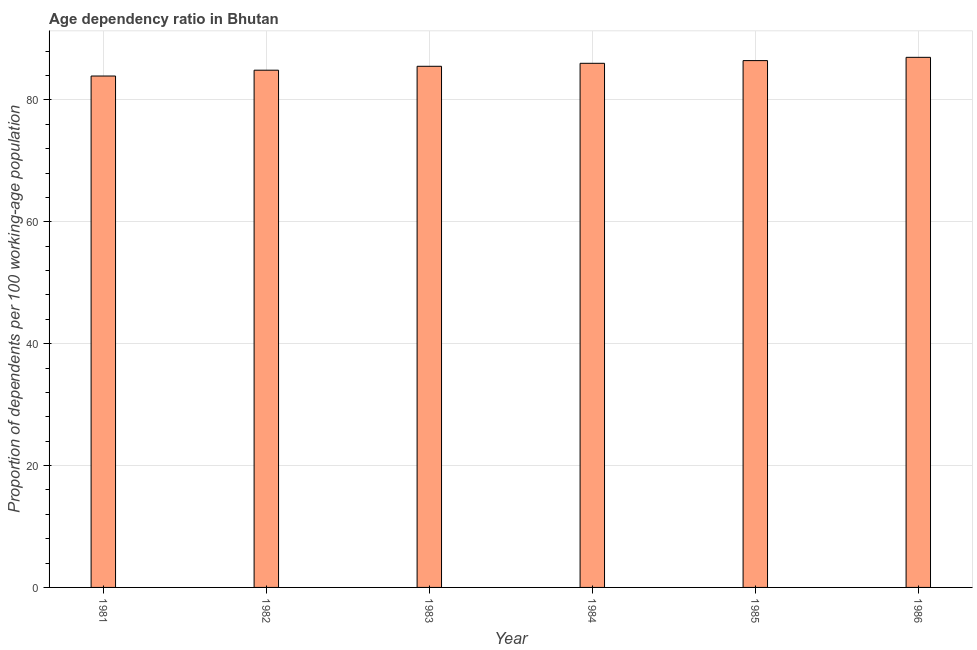Does the graph contain grids?
Offer a very short reply. Yes. What is the title of the graph?
Make the answer very short. Age dependency ratio in Bhutan. What is the label or title of the X-axis?
Provide a short and direct response. Year. What is the label or title of the Y-axis?
Your response must be concise. Proportion of dependents per 100 working-age population. What is the age dependency ratio in 1981?
Provide a succinct answer. 83.92. Across all years, what is the maximum age dependency ratio?
Make the answer very short. 86.99. Across all years, what is the minimum age dependency ratio?
Provide a short and direct response. 83.92. What is the sum of the age dependency ratio?
Give a very brief answer. 513.76. What is the difference between the age dependency ratio in 1982 and 1986?
Give a very brief answer. -2.11. What is the average age dependency ratio per year?
Your answer should be very brief. 85.63. What is the median age dependency ratio?
Your answer should be very brief. 85.76. Do a majority of the years between 1984 and 1983 (inclusive) have age dependency ratio greater than 52 ?
Your answer should be compact. No. What is the difference between the highest and the second highest age dependency ratio?
Offer a terse response. 0.54. Is the sum of the age dependency ratio in 1984 and 1986 greater than the maximum age dependency ratio across all years?
Provide a succinct answer. Yes. What is the difference between the highest and the lowest age dependency ratio?
Provide a succinct answer. 3.07. How many bars are there?
Offer a terse response. 6. How many years are there in the graph?
Keep it short and to the point. 6. What is the difference between two consecutive major ticks on the Y-axis?
Make the answer very short. 20. What is the Proportion of dependents per 100 working-age population of 1981?
Give a very brief answer. 83.92. What is the Proportion of dependents per 100 working-age population of 1982?
Provide a succinct answer. 84.88. What is the Proportion of dependents per 100 working-age population in 1983?
Ensure brevity in your answer.  85.52. What is the Proportion of dependents per 100 working-age population in 1984?
Offer a terse response. 86.01. What is the Proportion of dependents per 100 working-age population in 1985?
Ensure brevity in your answer.  86.45. What is the Proportion of dependents per 100 working-age population in 1986?
Provide a succinct answer. 86.99. What is the difference between the Proportion of dependents per 100 working-age population in 1981 and 1982?
Provide a short and direct response. -0.96. What is the difference between the Proportion of dependents per 100 working-age population in 1981 and 1983?
Your answer should be compact. -1.6. What is the difference between the Proportion of dependents per 100 working-age population in 1981 and 1984?
Offer a very short reply. -2.09. What is the difference between the Proportion of dependents per 100 working-age population in 1981 and 1985?
Offer a very short reply. -2.53. What is the difference between the Proportion of dependents per 100 working-age population in 1981 and 1986?
Keep it short and to the point. -3.07. What is the difference between the Proportion of dependents per 100 working-age population in 1982 and 1983?
Provide a short and direct response. -0.64. What is the difference between the Proportion of dependents per 100 working-age population in 1982 and 1984?
Make the answer very short. -1.13. What is the difference between the Proportion of dependents per 100 working-age population in 1982 and 1985?
Offer a terse response. -1.57. What is the difference between the Proportion of dependents per 100 working-age population in 1982 and 1986?
Ensure brevity in your answer.  -2.11. What is the difference between the Proportion of dependents per 100 working-age population in 1983 and 1984?
Provide a short and direct response. -0.49. What is the difference between the Proportion of dependents per 100 working-age population in 1983 and 1985?
Provide a short and direct response. -0.93. What is the difference between the Proportion of dependents per 100 working-age population in 1983 and 1986?
Provide a succinct answer. -1.47. What is the difference between the Proportion of dependents per 100 working-age population in 1984 and 1985?
Offer a terse response. -0.44. What is the difference between the Proportion of dependents per 100 working-age population in 1984 and 1986?
Provide a succinct answer. -0.98. What is the difference between the Proportion of dependents per 100 working-age population in 1985 and 1986?
Make the answer very short. -0.54. What is the ratio of the Proportion of dependents per 100 working-age population in 1981 to that in 1982?
Your answer should be very brief. 0.99. What is the ratio of the Proportion of dependents per 100 working-age population in 1981 to that in 1984?
Your response must be concise. 0.98. What is the ratio of the Proportion of dependents per 100 working-age population in 1982 to that in 1984?
Your answer should be compact. 0.99. What is the ratio of the Proportion of dependents per 100 working-age population in 1982 to that in 1986?
Your answer should be compact. 0.98. What is the ratio of the Proportion of dependents per 100 working-age population in 1983 to that in 1984?
Give a very brief answer. 0.99. What is the ratio of the Proportion of dependents per 100 working-age population in 1984 to that in 1986?
Offer a very short reply. 0.99. 